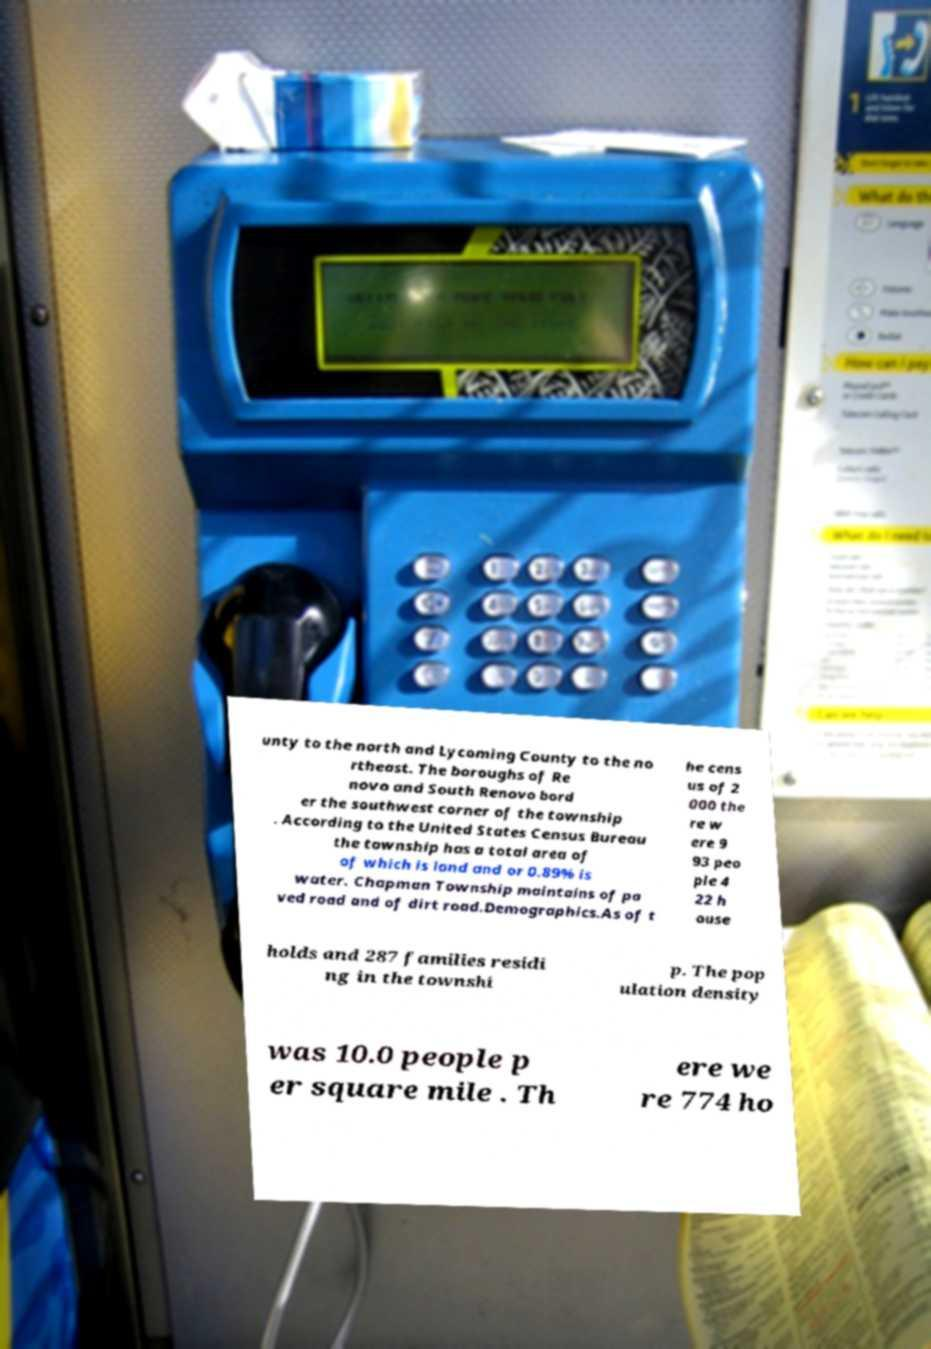Could you extract and type out the text from this image? unty to the north and Lycoming County to the no rtheast. The boroughs of Re novo and South Renovo bord er the southwest corner of the township . According to the United States Census Bureau the township has a total area of of which is land and or 0.89% is water. Chapman Township maintains of pa ved road and of dirt road.Demographics.As of t he cens us of 2 000 the re w ere 9 93 peo ple 4 22 h ouse holds and 287 families residi ng in the townshi p. The pop ulation density was 10.0 people p er square mile . Th ere we re 774 ho 